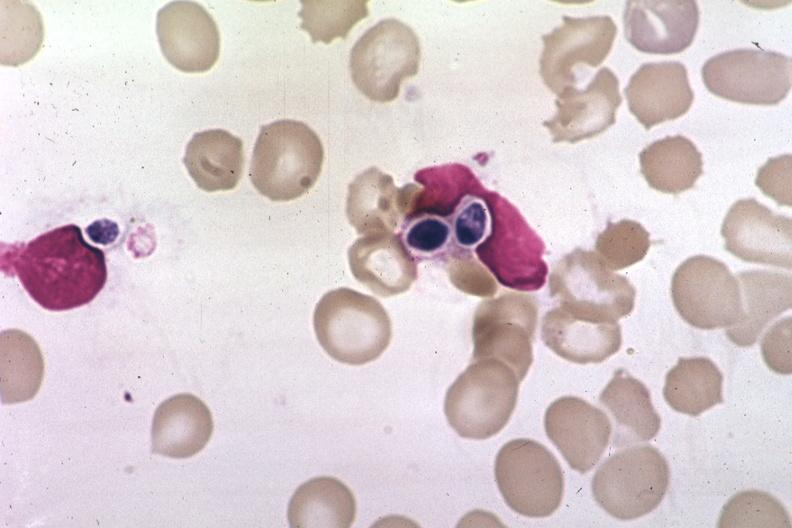does band constriction in skin above ankle of infant show wrights?
Answer the question using a single word or phrase. No 